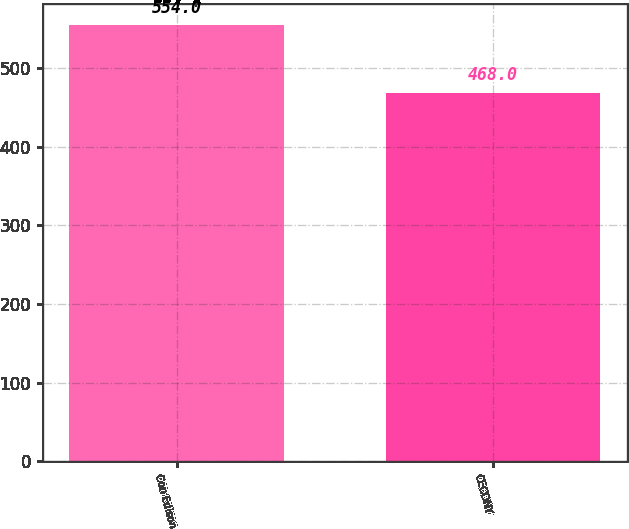Convert chart to OTSL. <chart><loc_0><loc_0><loc_500><loc_500><bar_chart><fcel>Con Edison<fcel>CECONY<nl><fcel>554<fcel>468<nl></chart> 